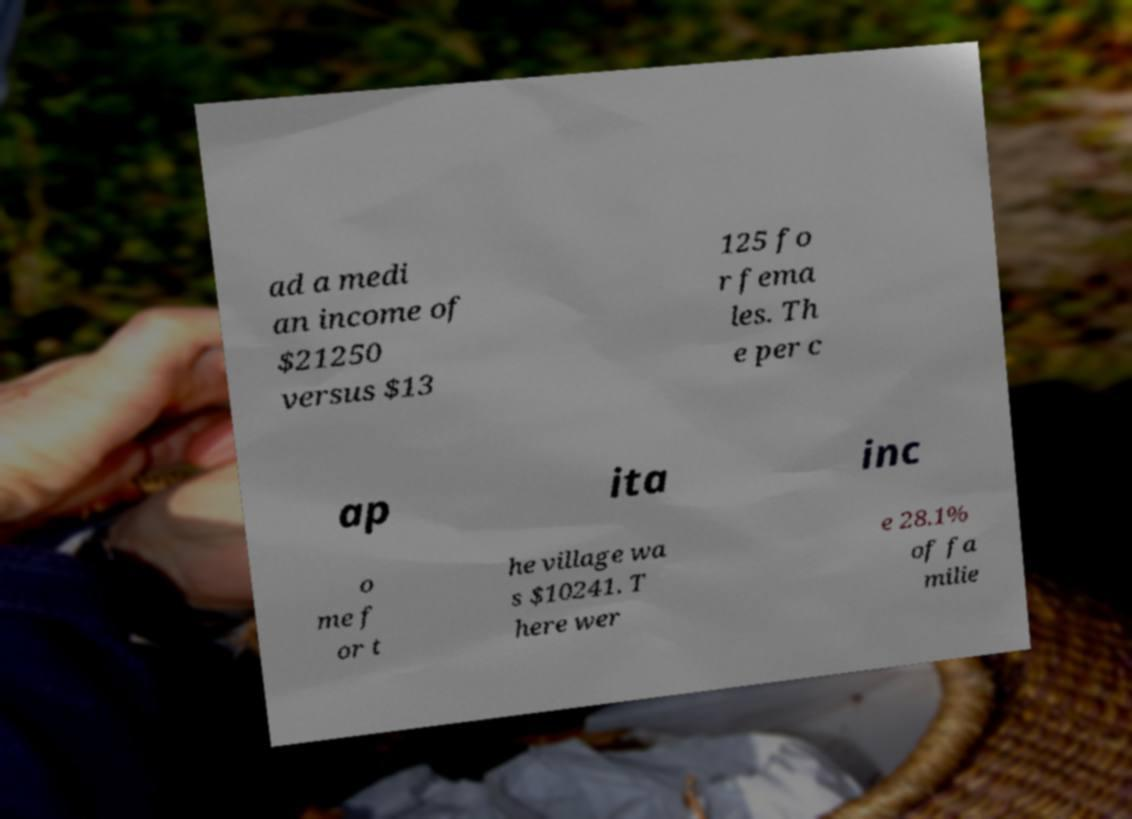Please identify and transcribe the text found in this image. ad a medi an income of $21250 versus $13 125 fo r fema les. Th e per c ap ita inc o me f or t he village wa s $10241. T here wer e 28.1% of fa milie 